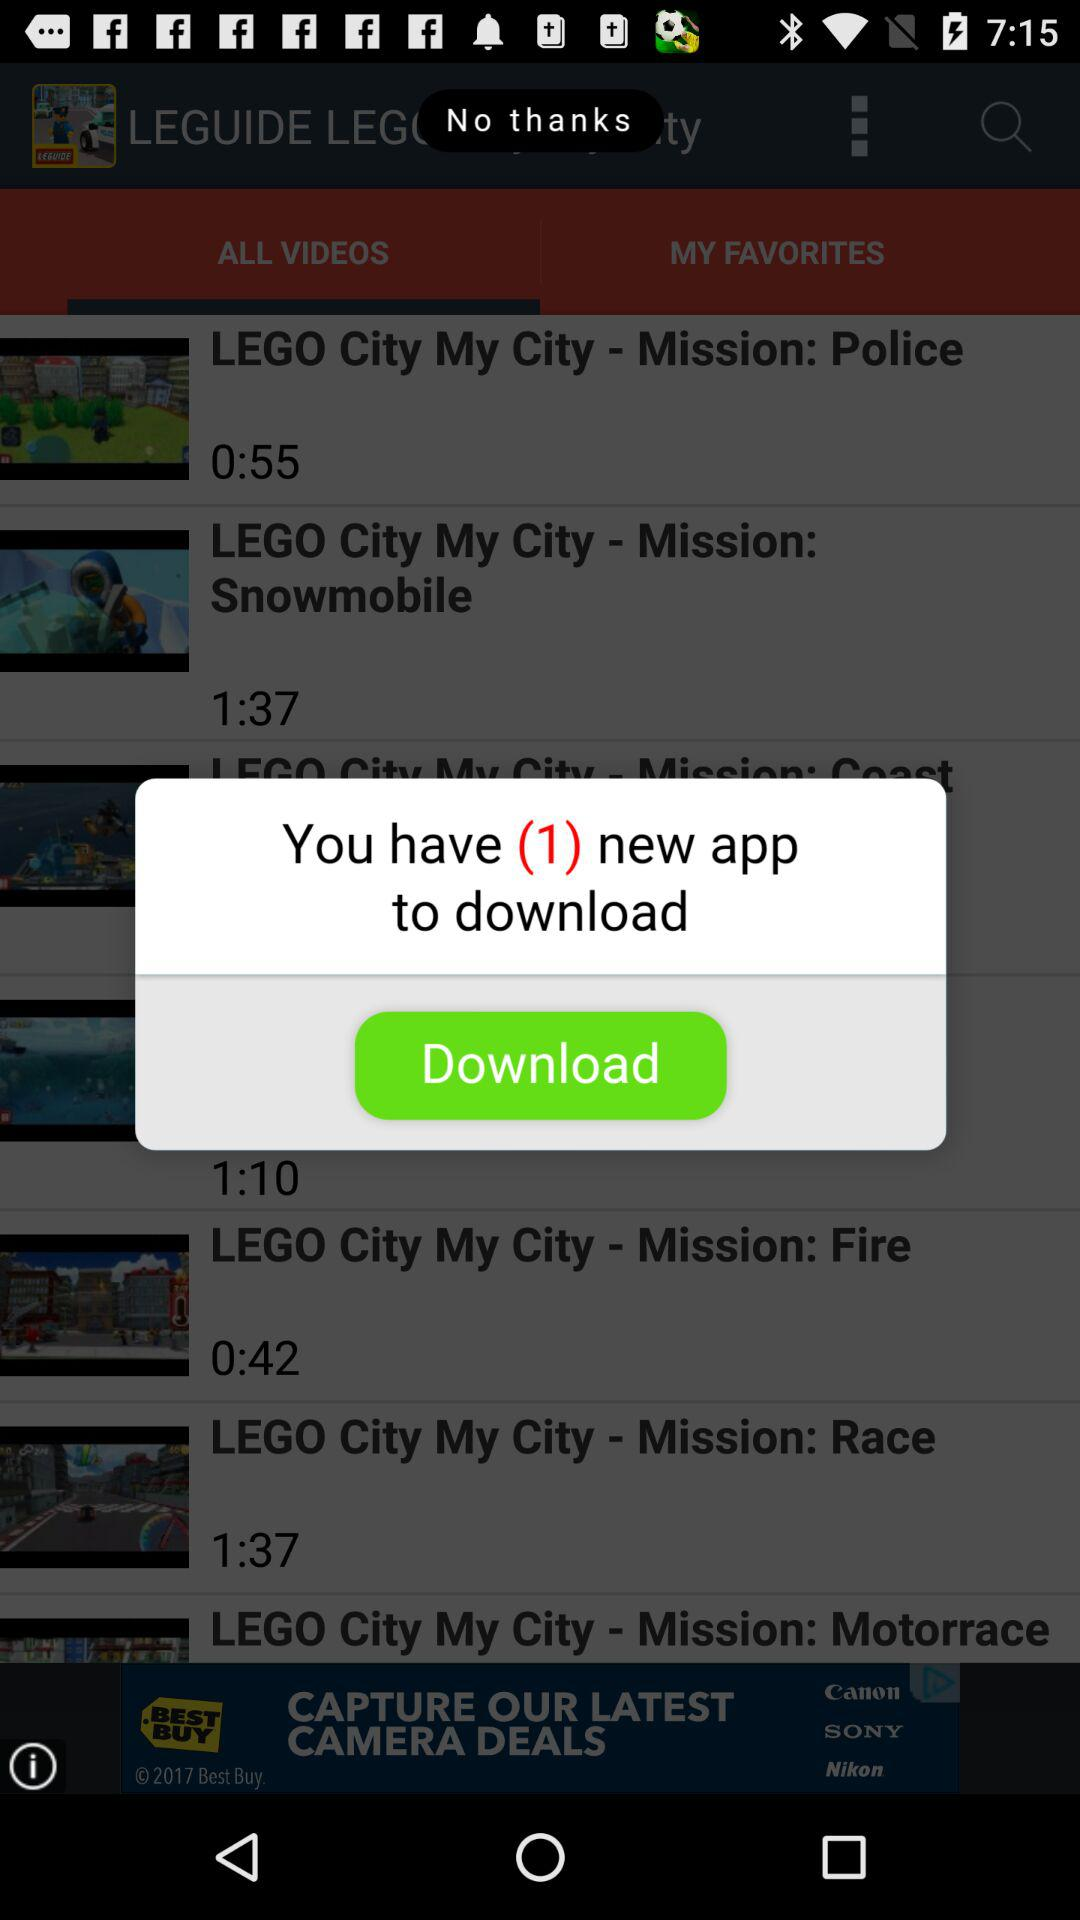Which tab is selected? The selected tab is "ALL VIDEOS". 